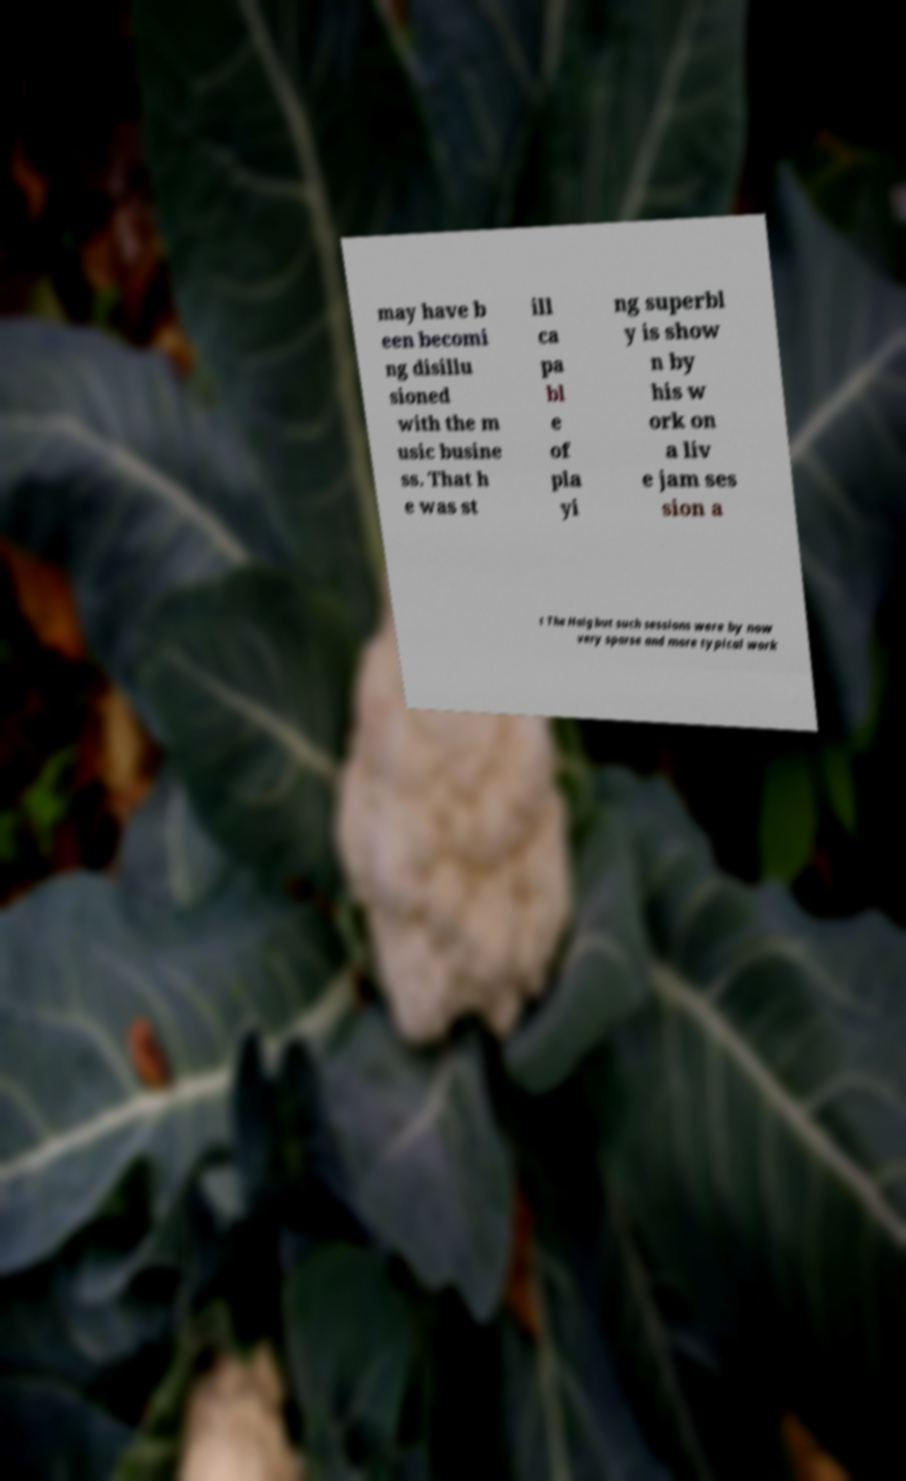Please read and relay the text visible in this image. What does it say? may have b een becomi ng disillu sioned with the m usic busine ss. That h e was st ill ca pa bl e of pla yi ng superbl y is show n by his w ork on a liv e jam ses sion a t The Haig but such sessions were by now very sparse and more typical work 